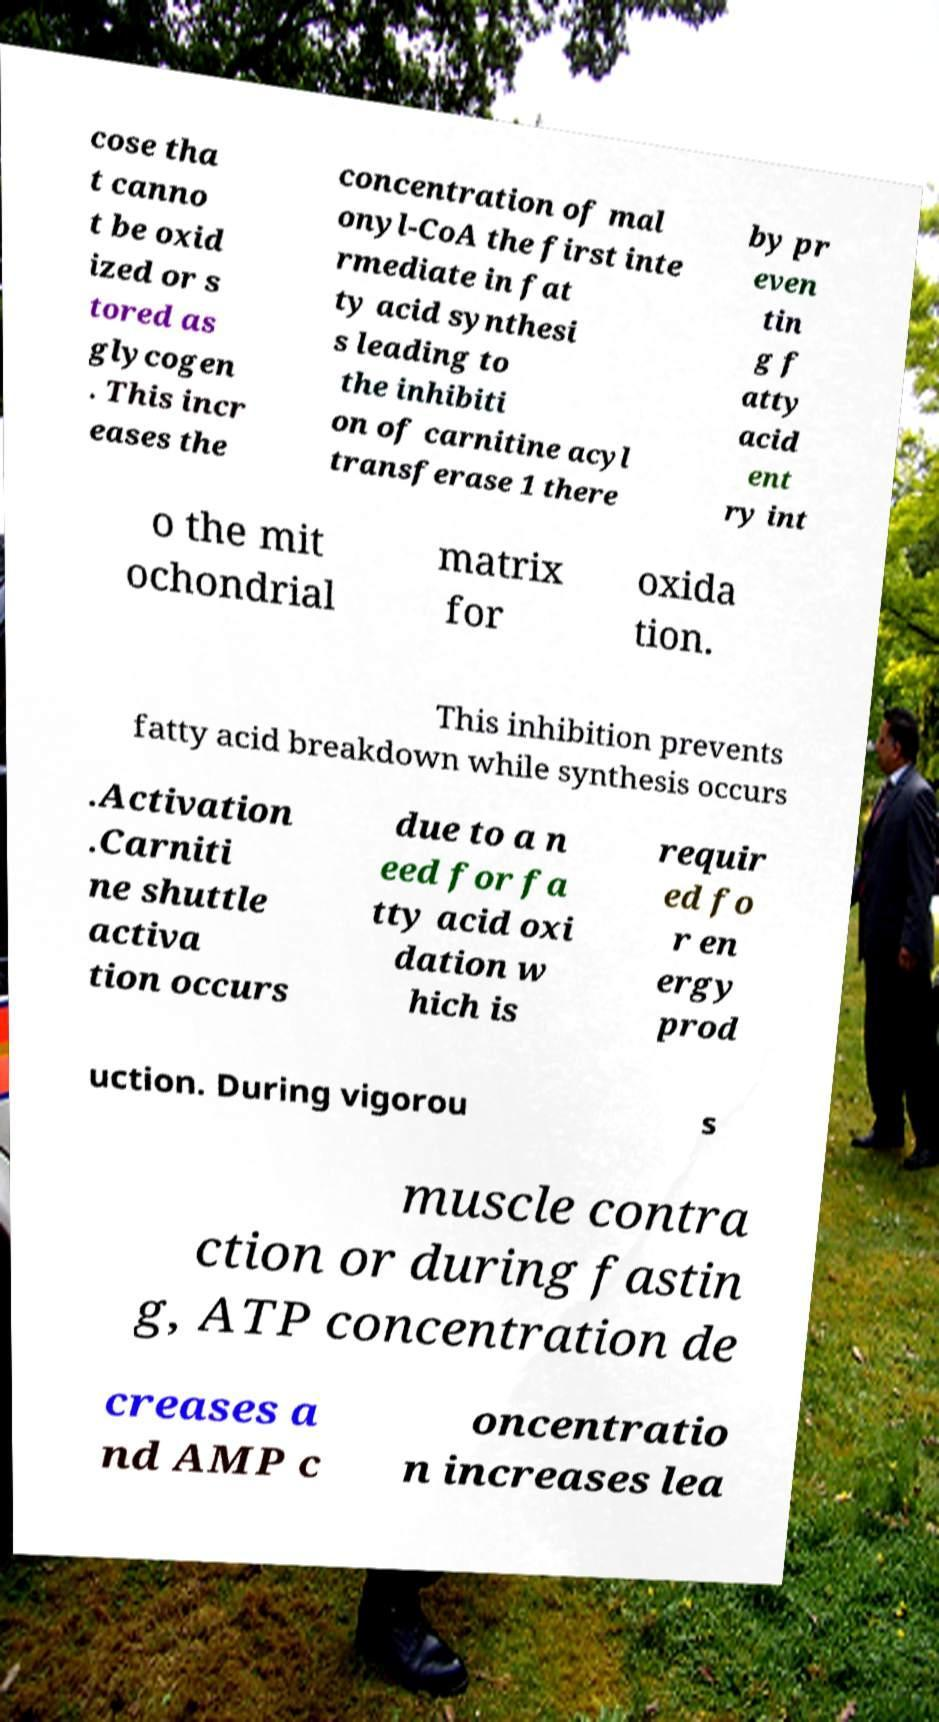Please identify and transcribe the text found in this image. cose tha t canno t be oxid ized or s tored as glycogen . This incr eases the concentration of mal onyl-CoA the first inte rmediate in fat ty acid synthesi s leading to the inhibiti on of carnitine acyl transferase 1 there by pr even tin g f atty acid ent ry int o the mit ochondrial matrix for oxida tion. This inhibition prevents fatty acid breakdown while synthesis occurs .Activation .Carniti ne shuttle activa tion occurs due to a n eed for fa tty acid oxi dation w hich is requir ed fo r en ergy prod uction. During vigorou s muscle contra ction or during fastin g, ATP concentration de creases a nd AMP c oncentratio n increases lea 